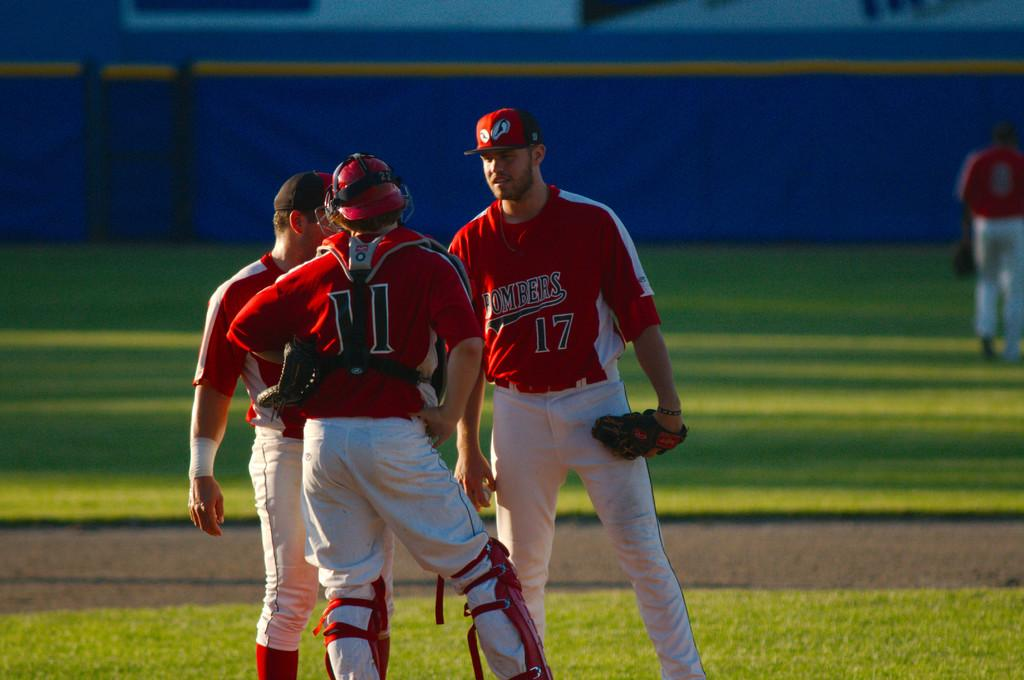<image>
Provide a brief description of the given image. Three members of the Bombers baseball team confer during a game. 